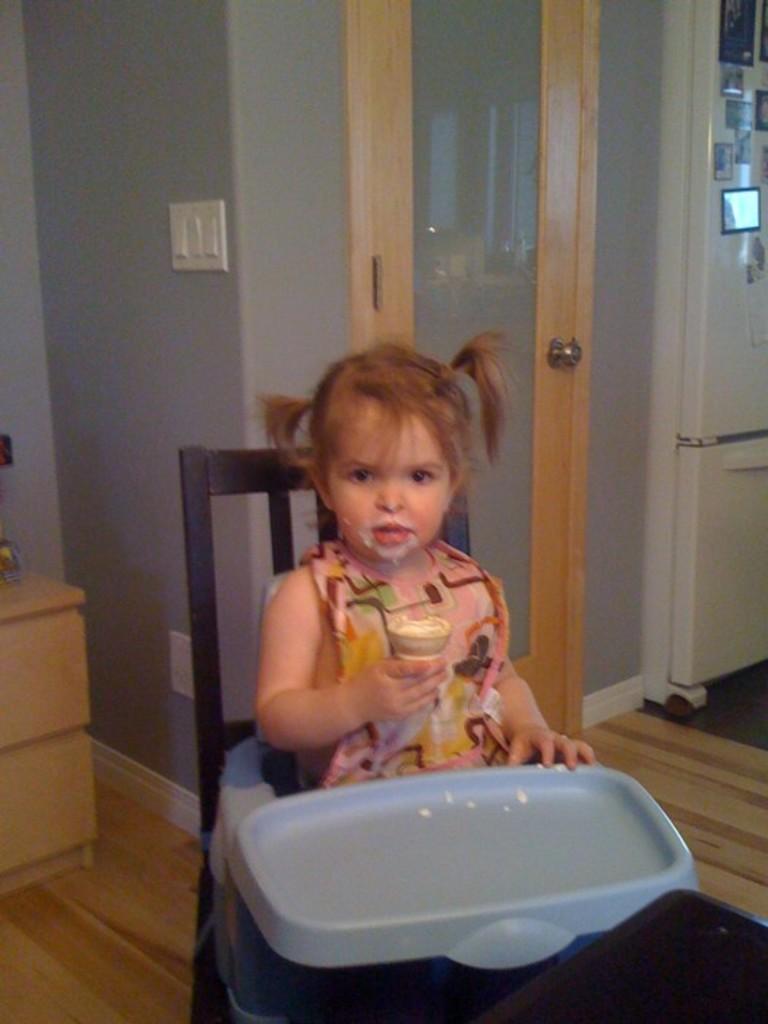Could you give a brief overview of what you see in this image? In this image in the front there is a girl sitting on a chair holding an ice cream in her hand. In the background there is door and on the right side there is a refrigerator which is white in colour. On the left side there is a wooden stand and there is a wall which is gray in colour. 